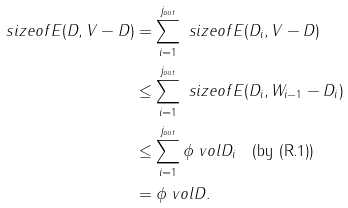<formula> <loc_0><loc_0><loc_500><loc_500>\ s i z e o f { E ( D , V - D ) } & = \sum _ { i = 1 } ^ { j _ { o u t } } \ s i z e o f { E ( D _ { i } , V - D ) } \\ & \leq \sum _ { i = 1 } ^ { j _ { o u t } } \ s i z e o f { E ( D _ { i } , W _ { i - 1 } - D _ { i } ) } \\ & \leq \sum _ { i = 1 } ^ { j _ { o u t } } \phi \ v o l { D _ { i } } \quad \text {(by (R.1))} \\ & = \phi \ v o l { D } .</formula> 